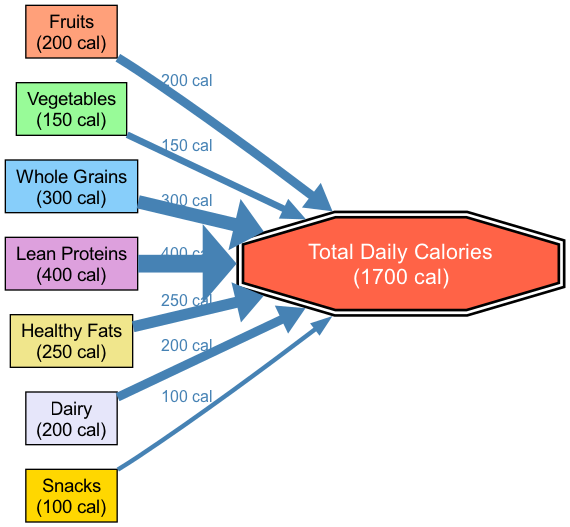What's the contribution of Lean Proteins? The diagram shows Lean Proteins with a contribution of 400 calories, clearly labeled next to the node for Lean Proteins.
Answer: 400 calories How many calorie contributions are there from Snacks? The Snacks node indicates a contribution of 100 calories, which is shown directly next to that node in the diagram.
Answer: 100 calories Which food group contributes the most calories? By comparing the contributions, Lean Proteins at 400 calories has the highest value among all the food groups represented in the diagram.
Answer: Lean Proteins What is the total number of nodes in the diagram? The diagram contains eight nodes, which include types of food and the Total Daily Calories node. This can be counted directly from the node list.
Answer: 8 What percentage of total calories comes from Whole Grains? Whole Grains contribute 300 calories. To find the percentage, calculate (300 / 1700) * 100 = 17.65%. This is derived from the contribution values and the Total Daily Calories.
Answer: 17.65% How do Fruits and Vegetables compare in calorie contribution? Fruits contribute 200 calories and Vegetables contribute 150 calories. Fruits contribute 50 calories more than Vegetables, which can be determined by subtracting the two values.
Answer: Fruits contribute 50 more calories Which food source contributes the least calories? Snacks, with a contribution of 100 calories, is the lowest contribution shown in the diagram when compared to other food groups.
Answer: Snacks If you combined the calories from Dairy and Healthy Fats, what would that total be? To find the total of Dairy and Healthy Fats, add their contributions: Dairy (200 calories) + Healthy Fats (250 calories) = 450 calories. This requires summing the two values shown on their respective nodes.
Answer: 450 calories What is the color coding scheme used for the food groups? The diagram employs a custom color palette to visually differentiate each food group. Each food group node is filled with one of the selected colors from this palette, following the order of inclusion.
Answer: Unique colors for each group 